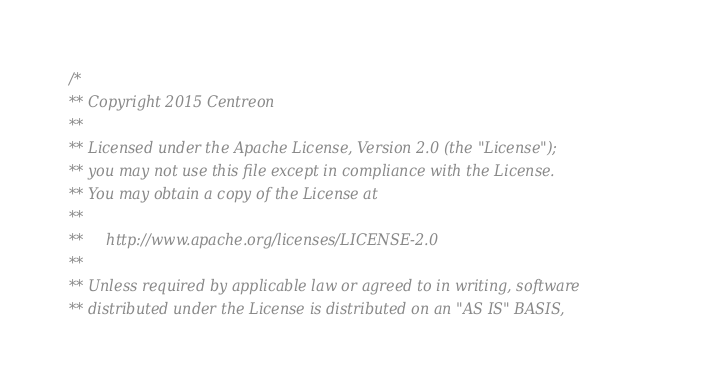<code> <loc_0><loc_0><loc_500><loc_500><_C++_>/*
** Copyright 2015 Centreon
**
** Licensed under the Apache License, Version 2.0 (the "License");
** you may not use this file except in compliance with the License.
** You may obtain a copy of the License at
**
**     http://www.apache.org/licenses/LICENSE-2.0
**
** Unless required by applicable law or agreed to in writing, software
** distributed under the License is distributed on an "AS IS" BASIS,</code> 